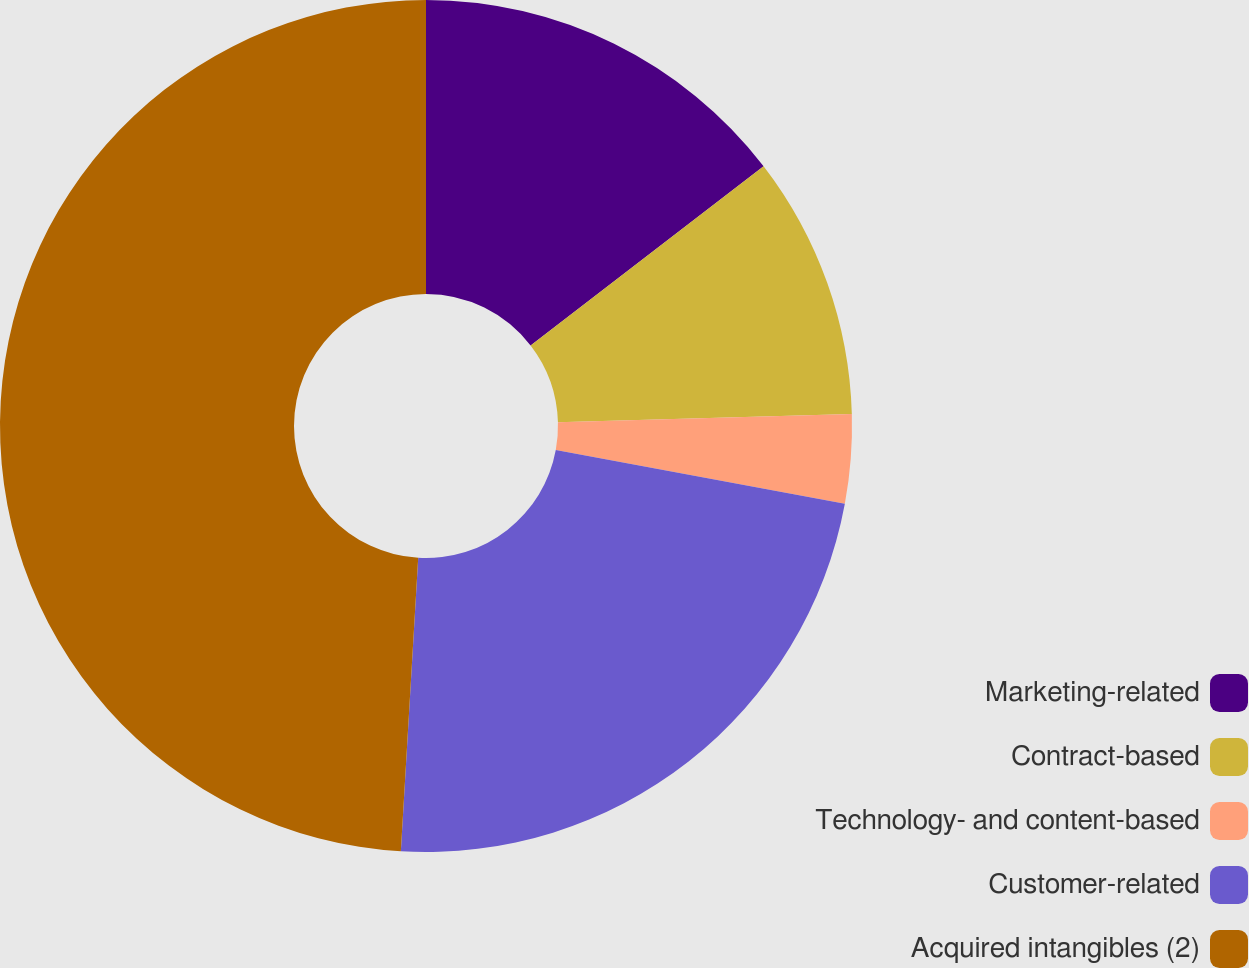<chart> <loc_0><loc_0><loc_500><loc_500><pie_chart><fcel>Marketing-related<fcel>Contract-based<fcel>Technology- and content-based<fcel>Customer-related<fcel>Acquired intangibles (2)<nl><fcel>14.56%<fcel>9.99%<fcel>3.37%<fcel>23.02%<fcel>49.06%<nl></chart> 